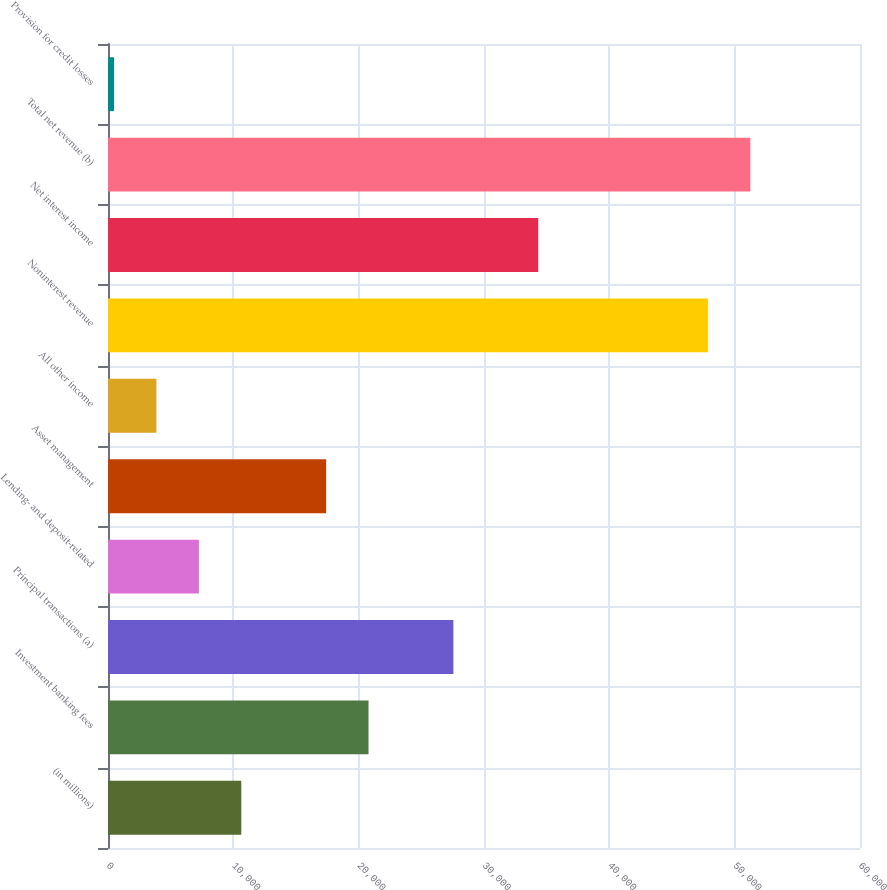Convert chart. <chart><loc_0><loc_0><loc_500><loc_500><bar_chart><fcel>(in millions)<fcel>Investment banking fees<fcel>Principal transactions (a)<fcel>Lending- and deposit-related<fcel>Asset management<fcel>All other income<fcel>Noninterest revenue<fcel>Net interest income<fcel>Total net revenue (b)<fcel>Provision for credit losses<nl><fcel>10633.1<fcel>20787.2<fcel>27556.6<fcel>7248.4<fcel>17402.5<fcel>3863.7<fcel>47864.8<fcel>34326<fcel>51249.5<fcel>479<nl></chart> 